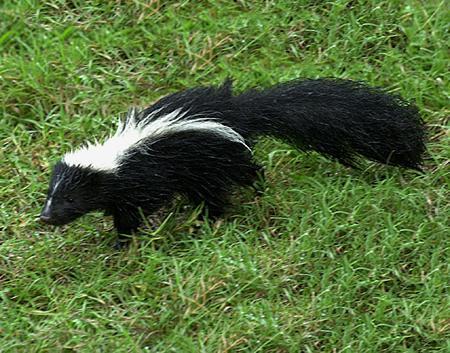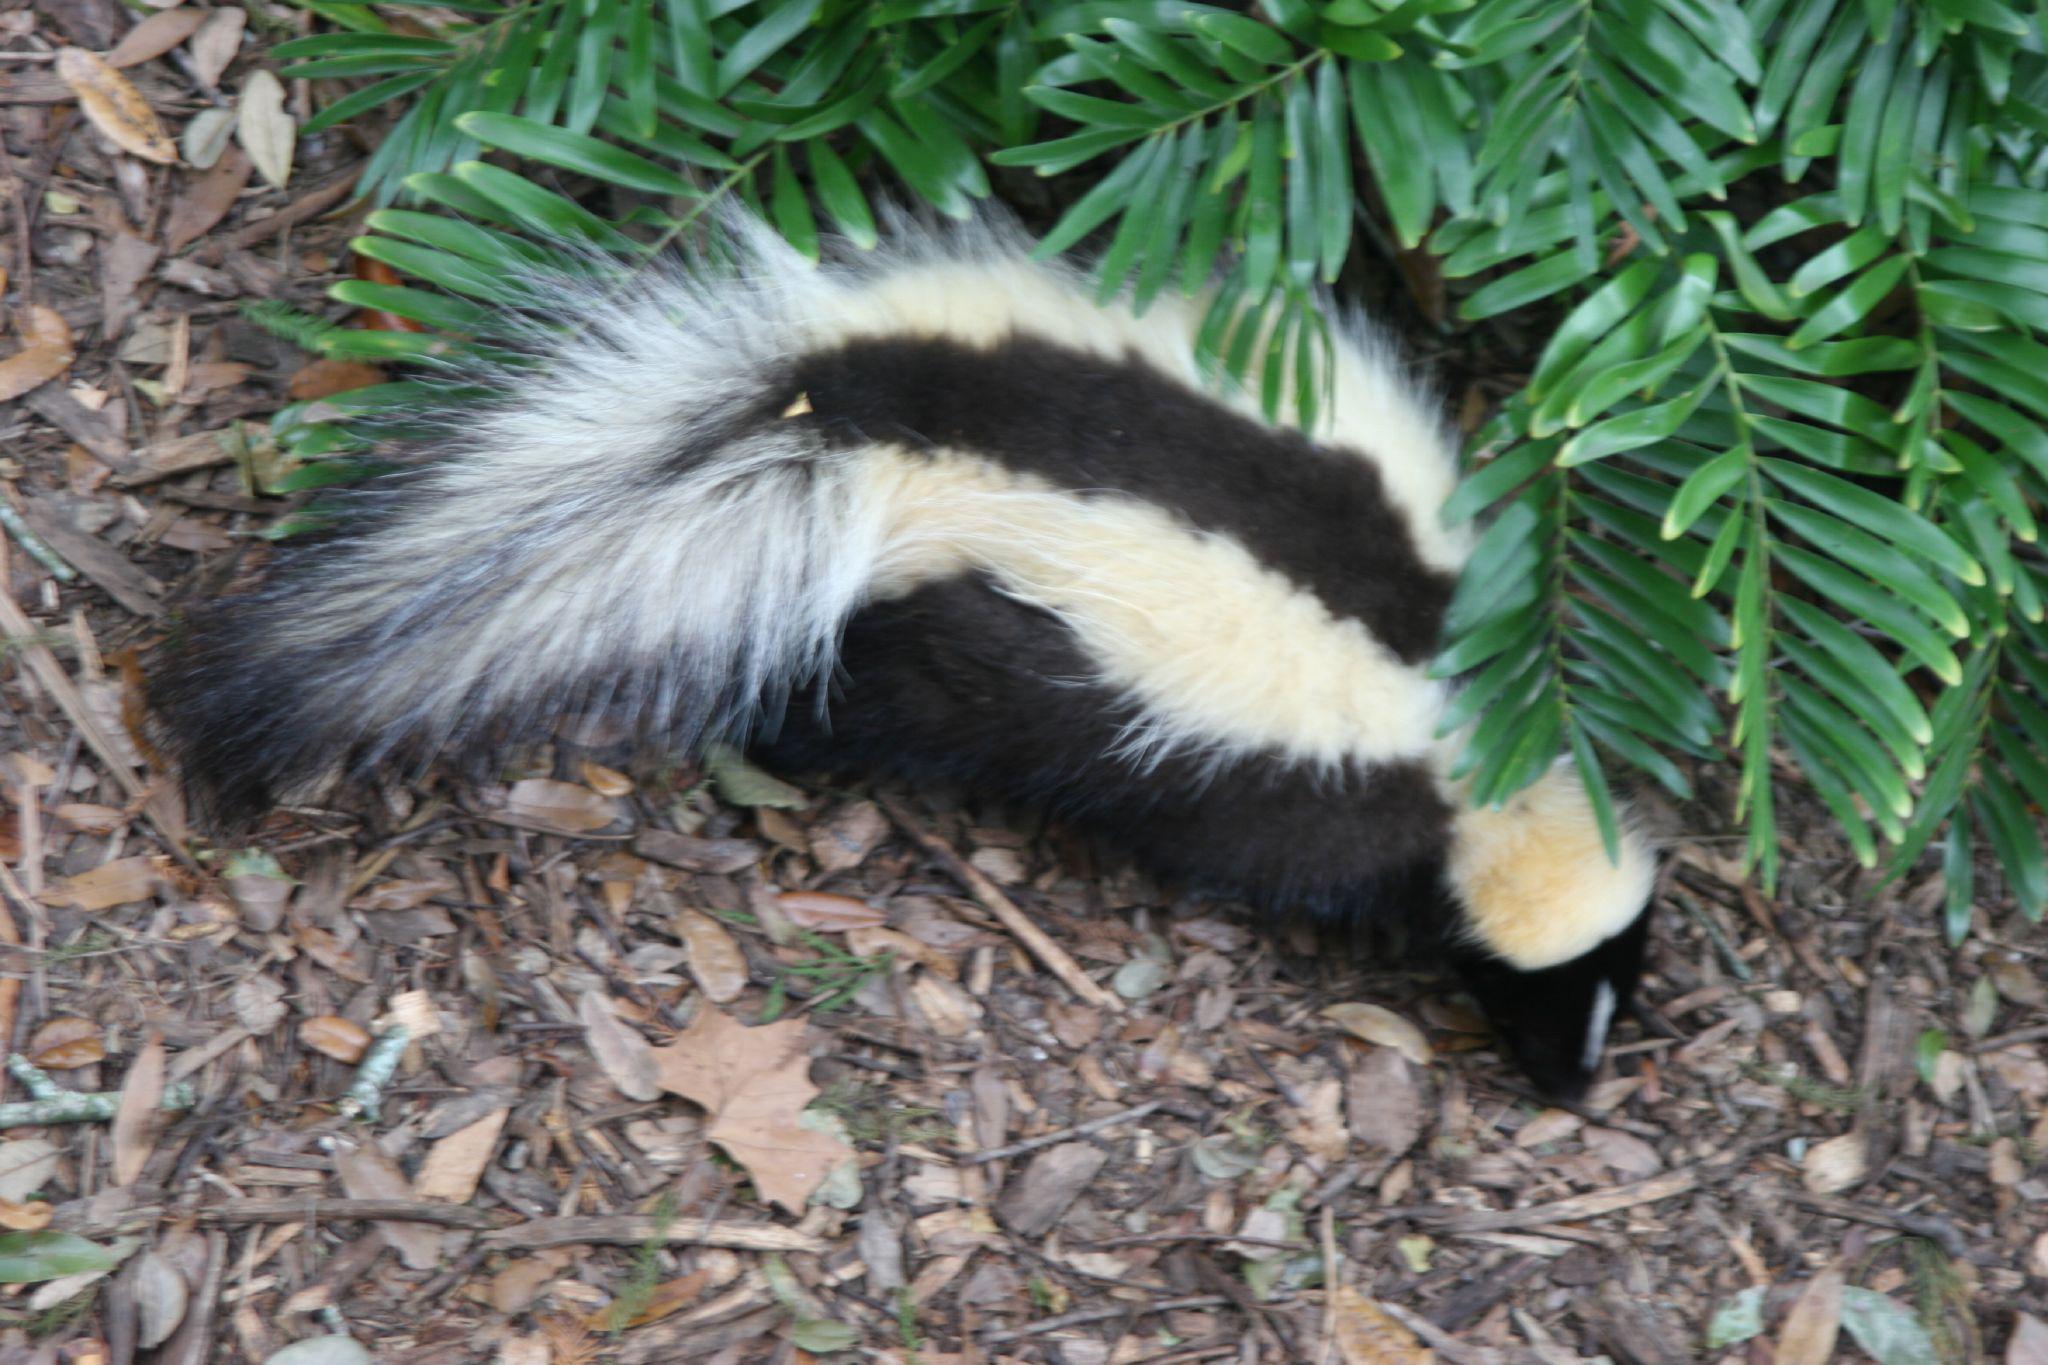The first image is the image on the left, the second image is the image on the right. Evaluate the accuracy of this statement regarding the images: "One tail is a solid color.". Is it true? Answer yes or no. Yes. The first image is the image on the left, the second image is the image on the right. Examine the images to the left and right. Is the description "The single skunk on the right has a bold straight white stripe and stands in profile, and the single skunk on the left has curving, maze-like stripes." accurate? Answer yes or no. No. 